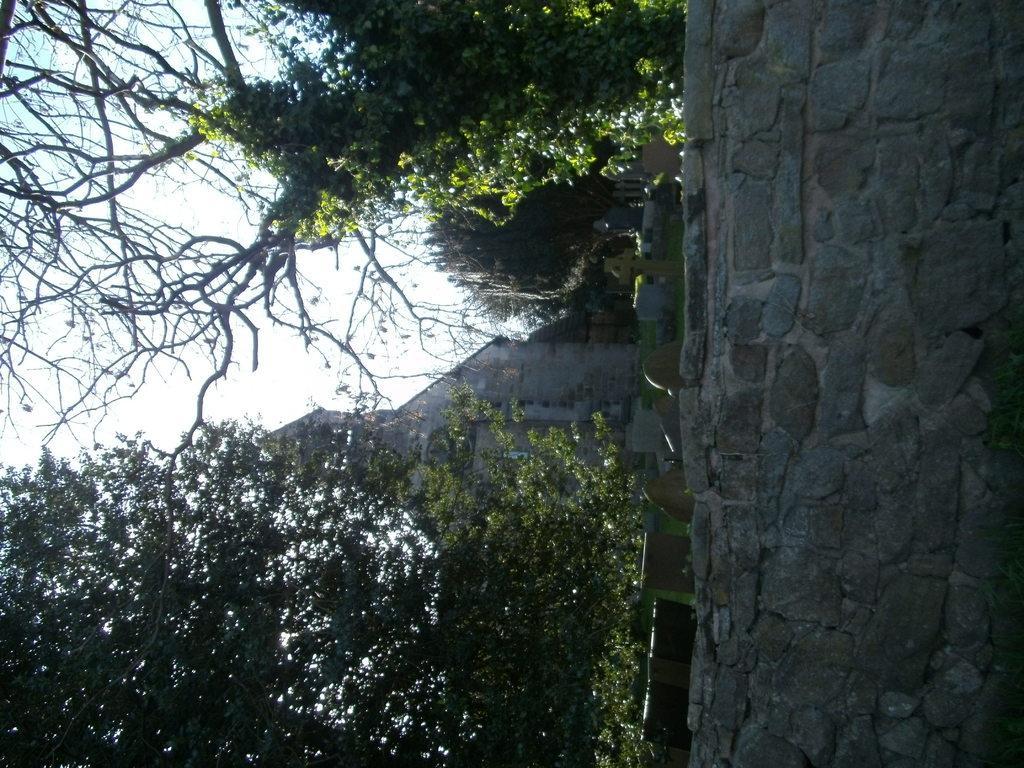Describe this image in one or two sentences. In this image we can see building, trees, wall, grave and sky. 